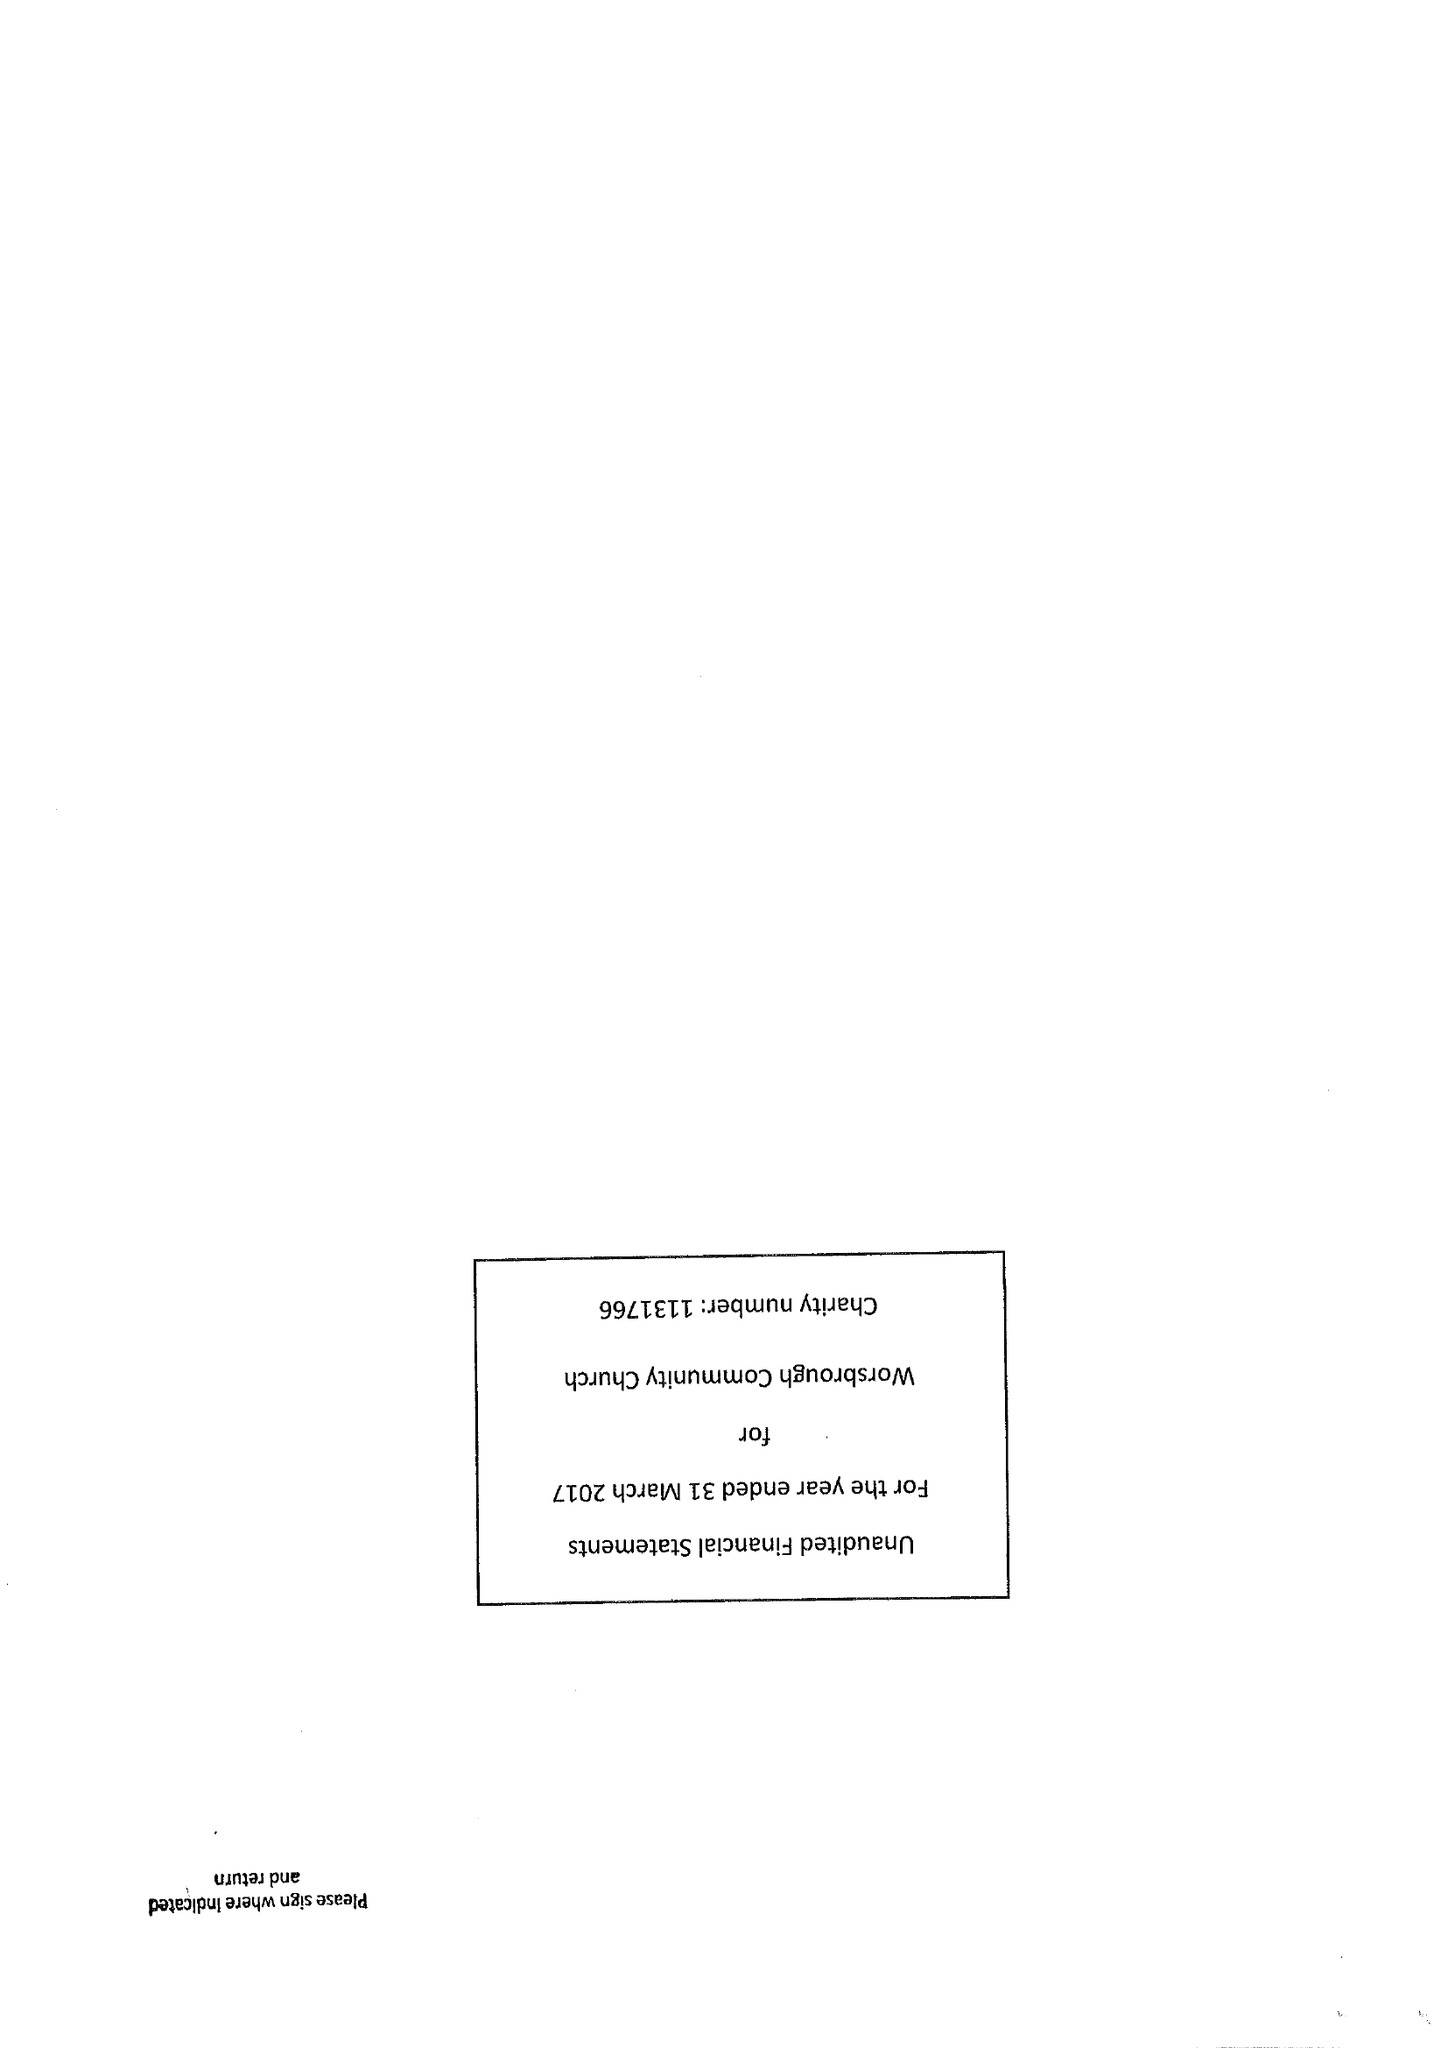What is the value for the charity_number?
Answer the question using a single word or phrase. 1131766 